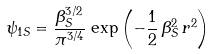<formula> <loc_0><loc_0><loc_500><loc_500>\psi _ { 1 S } = \frac { \beta _ { S } ^ { 3 / 2 } } { \pi ^ { 3 / 4 } } \, \exp { \left ( - \frac { 1 } { 2 } \, \beta _ { S } ^ { 2 } \, r ^ { 2 } \right ) }</formula> 